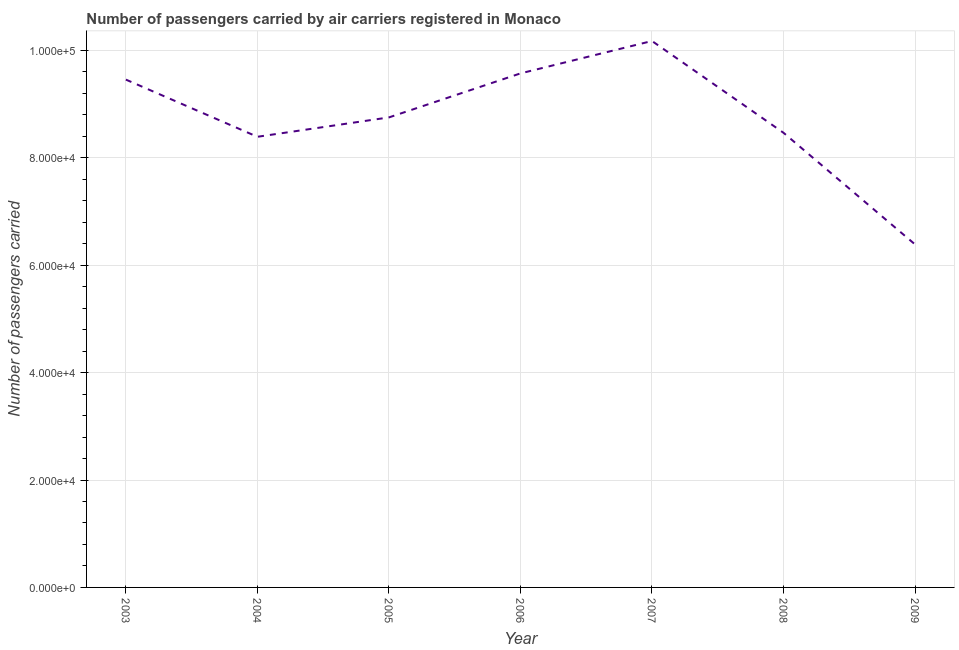What is the number of passengers carried in 2003?
Provide a succinct answer. 9.46e+04. Across all years, what is the maximum number of passengers carried?
Your response must be concise. 1.02e+05. Across all years, what is the minimum number of passengers carried?
Give a very brief answer. 6.39e+04. In which year was the number of passengers carried minimum?
Offer a terse response. 2009. What is the sum of the number of passengers carried?
Your response must be concise. 6.12e+05. What is the difference between the number of passengers carried in 2003 and 2008?
Your answer should be very brief. 9903. What is the average number of passengers carried per year?
Ensure brevity in your answer.  8.74e+04. What is the median number of passengers carried?
Your answer should be very brief. 8.75e+04. What is the ratio of the number of passengers carried in 2004 to that in 2007?
Offer a terse response. 0.82. Is the number of passengers carried in 2006 less than that in 2007?
Your response must be concise. Yes. What is the difference between the highest and the second highest number of passengers carried?
Your answer should be very brief. 6032. Is the sum of the number of passengers carried in 2003 and 2008 greater than the maximum number of passengers carried across all years?
Make the answer very short. Yes. What is the difference between the highest and the lowest number of passengers carried?
Your response must be concise. 3.79e+04. Does the number of passengers carried monotonically increase over the years?
Your answer should be very brief. No. How many lines are there?
Your response must be concise. 1. What is the difference between two consecutive major ticks on the Y-axis?
Your answer should be very brief. 2.00e+04. Does the graph contain any zero values?
Provide a short and direct response. No. Does the graph contain grids?
Your answer should be compact. Yes. What is the title of the graph?
Give a very brief answer. Number of passengers carried by air carriers registered in Monaco. What is the label or title of the X-axis?
Offer a very short reply. Year. What is the label or title of the Y-axis?
Give a very brief answer. Number of passengers carried. What is the Number of passengers carried of 2003?
Provide a short and direct response. 9.46e+04. What is the Number of passengers carried in 2004?
Provide a short and direct response. 8.39e+04. What is the Number of passengers carried in 2005?
Give a very brief answer. 8.75e+04. What is the Number of passengers carried in 2006?
Provide a succinct answer. 9.57e+04. What is the Number of passengers carried of 2007?
Your answer should be very brief. 1.02e+05. What is the Number of passengers carried of 2008?
Make the answer very short. 8.47e+04. What is the Number of passengers carried of 2009?
Offer a very short reply. 6.39e+04. What is the difference between the Number of passengers carried in 2003 and 2004?
Offer a terse response. 1.06e+04. What is the difference between the Number of passengers carried in 2003 and 2005?
Offer a terse response. 7040. What is the difference between the Number of passengers carried in 2003 and 2006?
Your response must be concise. -1158. What is the difference between the Number of passengers carried in 2003 and 2007?
Make the answer very short. -7190. What is the difference between the Number of passengers carried in 2003 and 2008?
Your response must be concise. 9903. What is the difference between the Number of passengers carried in 2003 and 2009?
Provide a short and direct response. 3.07e+04. What is the difference between the Number of passengers carried in 2004 and 2005?
Provide a succinct answer. -3607. What is the difference between the Number of passengers carried in 2004 and 2006?
Offer a very short reply. -1.18e+04. What is the difference between the Number of passengers carried in 2004 and 2007?
Give a very brief answer. -1.78e+04. What is the difference between the Number of passengers carried in 2004 and 2008?
Provide a succinct answer. -744. What is the difference between the Number of passengers carried in 2004 and 2009?
Your response must be concise. 2.00e+04. What is the difference between the Number of passengers carried in 2005 and 2006?
Provide a succinct answer. -8198. What is the difference between the Number of passengers carried in 2005 and 2007?
Your answer should be very brief. -1.42e+04. What is the difference between the Number of passengers carried in 2005 and 2008?
Offer a very short reply. 2863. What is the difference between the Number of passengers carried in 2005 and 2009?
Offer a terse response. 2.36e+04. What is the difference between the Number of passengers carried in 2006 and 2007?
Offer a terse response. -6032. What is the difference between the Number of passengers carried in 2006 and 2008?
Provide a short and direct response. 1.11e+04. What is the difference between the Number of passengers carried in 2006 and 2009?
Keep it short and to the point. 3.18e+04. What is the difference between the Number of passengers carried in 2007 and 2008?
Offer a very short reply. 1.71e+04. What is the difference between the Number of passengers carried in 2007 and 2009?
Your answer should be very brief. 3.79e+04. What is the difference between the Number of passengers carried in 2008 and 2009?
Provide a short and direct response. 2.08e+04. What is the ratio of the Number of passengers carried in 2003 to that in 2004?
Your answer should be compact. 1.13. What is the ratio of the Number of passengers carried in 2003 to that in 2005?
Ensure brevity in your answer.  1.08. What is the ratio of the Number of passengers carried in 2003 to that in 2006?
Keep it short and to the point. 0.99. What is the ratio of the Number of passengers carried in 2003 to that in 2007?
Make the answer very short. 0.93. What is the ratio of the Number of passengers carried in 2003 to that in 2008?
Provide a succinct answer. 1.12. What is the ratio of the Number of passengers carried in 2003 to that in 2009?
Keep it short and to the point. 1.48. What is the ratio of the Number of passengers carried in 2004 to that in 2006?
Offer a terse response. 0.88. What is the ratio of the Number of passengers carried in 2004 to that in 2007?
Ensure brevity in your answer.  0.82. What is the ratio of the Number of passengers carried in 2004 to that in 2009?
Offer a very short reply. 1.31. What is the ratio of the Number of passengers carried in 2005 to that in 2006?
Give a very brief answer. 0.91. What is the ratio of the Number of passengers carried in 2005 to that in 2007?
Give a very brief answer. 0.86. What is the ratio of the Number of passengers carried in 2005 to that in 2008?
Ensure brevity in your answer.  1.03. What is the ratio of the Number of passengers carried in 2005 to that in 2009?
Provide a succinct answer. 1.37. What is the ratio of the Number of passengers carried in 2006 to that in 2007?
Offer a terse response. 0.94. What is the ratio of the Number of passengers carried in 2006 to that in 2008?
Provide a short and direct response. 1.13. What is the ratio of the Number of passengers carried in 2006 to that in 2009?
Offer a terse response. 1.5. What is the ratio of the Number of passengers carried in 2007 to that in 2008?
Offer a terse response. 1.2. What is the ratio of the Number of passengers carried in 2007 to that in 2009?
Your response must be concise. 1.59. What is the ratio of the Number of passengers carried in 2008 to that in 2009?
Your answer should be compact. 1.32. 